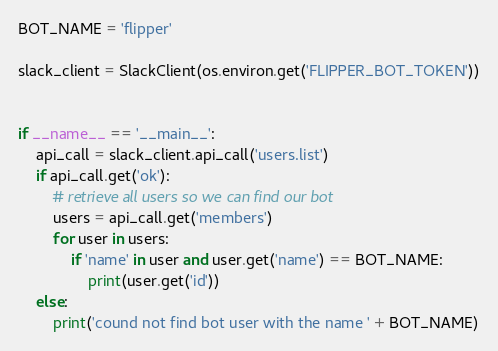<code> <loc_0><loc_0><loc_500><loc_500><_Python_>BOT_NAME = 'flipper'

slack_client = SlackClient(os.environ.get('FLIPPER_BOT_TOKEN'))


if __name__ == '__main__':
    api_call = slack_client.api_call('users.list')
    if api_call.get('ok'):
        # retrieve all users so we can find our bot
        users = api_call.get('members')
        for user in users:
            if 'name' in user and user.get('name') == BOT_NAME:
                print(user.get('id'))
    else:
        print('cound not find bot user with the name ' + BOT_NAME)
</code> 